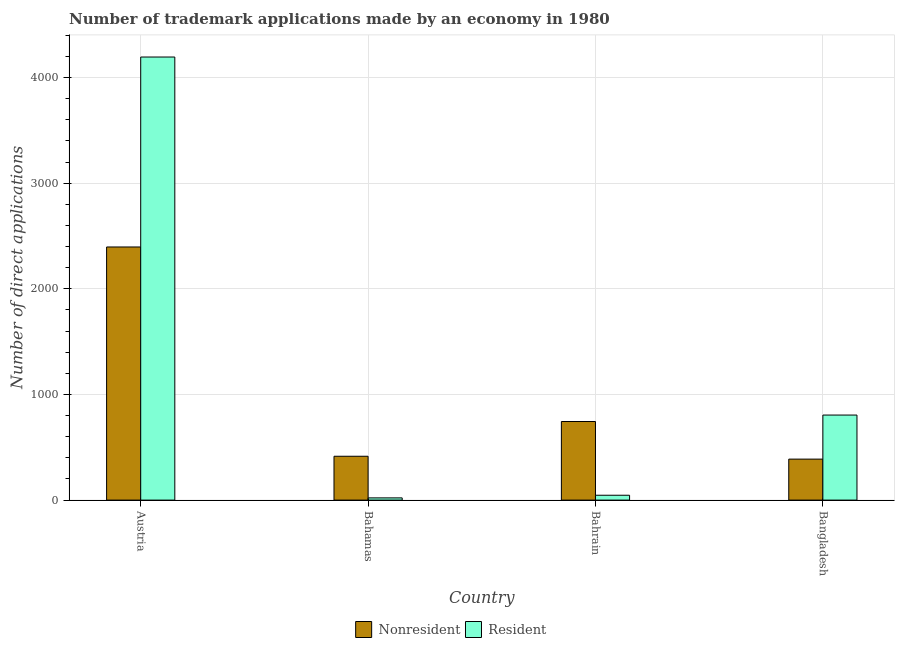Are the number of bars on each tick of the X-axis equal?
Your answer should be very brief. Yes. How many bars are there on the 2nd tick from the left?
Give a very brief answer. 2. How many bars are there on the 2nd tick from the right?
Your response must be concise. 2. What is the label of the 3rd group of bars from the left?
Provide a succinct answer. Bahrain. What is the number of trademark applications made by non residents in Bahrain?
Your answer should be compact. 744. Across all countries, what is the maximum number of trademark applications made by residents?
Give a very brief answer. 4194. Across all countries, what is the minimum number of trademark applications made by non residents?
Your response must be concise. 388. What is the total number of trademark applications made by residents in the graph?
Your response must be concise. 5066. What is the difference between the number of trademark applications made by non residents in Austria and that in Bahrain?
Provide a succinct answer. 1652. What is the difference between the number of trademark applications made by residents in Bangladesh and the number of trademark applications made by non residents in Bahrain?
Make the answer very short. 61. What is the average number of trademark applications made by residents per country?
Ensure brevity in your answer.  1266.5. What is the difference between the number of trademark applications made by non residents and number of trademark applications made by residents in Bahamas?
Offer a very short reply. 394. In how many countries, is the number of trademark applications made by residents greater than 1600 ?
Give a very brief answer. 1. What is the ratio of the number of trademark applications made by residents in Bahrain to that in Bangladesh?
Your response must be concise. 0.06. Is the number of trademark applications made by residents in Austria less than that in Bangladesh?
Your answer should be compact. No. Is the difference between the number of trademark applications made by residents in Bahamas and Bangladesh greater than the difference between the number of trademark applications made by non residents in Bahamas and Bangladesh?
Make the answer very short. No. What is the difference between the highest and the second highest number of trademark applications made by non residents?
Provide a succinct answer. 1652. What is the difference between the highest and the lowest number of trademark applications made by residents?
Make the answer very short. 4173. In how many countries, is the number of trademark applications made by non residents greater than the average number of trademark applications made by non residents taken over all countries?
Offer a terse response. 1. What does the 1st bar from the left in Bangladesh represents?
Your answer should be very brief. Nonresident. What does the 2nd bar from the right in Bahamas represents?
Your answer should be very brief. Nonresident. How many bars are there?
Offer a terse response. 8. What is the difference between two consecutive major ticks on the Y-axis?
Ensure brevity in your answer.  1000. Does the graph contain any zero values?
Your answer should be compact. No. Does the graph contain grids?
Ensure brevity in your answer.  Yes. Where does the legend appear in the graph?
Provide a short and direct response. Bottom center. How many legend labels are there?
Your response must be concise. 2. How are the legend labels stacked?
Make the answer very short. Horizontal. What is the title of the graph?
Provide a short and direct response. Number of trademark applications made by an economy in 1980. What is the label or title of the X-axis?
Provide a succinct answer. Country. What is the label or title of the Y-axis?
Offer a terse response. Number of direct applications. What is the Number of direct applications of Nonresident in Austria?
Offer a very short reply. 2396. What is the Number of direct applications in Resident in Austria?
Provide a short and direct response. 4194. What is the Number of direct applications in Nonresident in Bahamas?
Keep it short and to the point. 415. What is the Number of direct applications of Nonresident in Bahrain?
Offer a terse response. 744. What is the Number of direct applications of Nonresident in Bangladesh?
Provide a succinct answer. 388. What is the Number of direct applications in Resident in Bangladesh?
Your answer should be very brief. 805. Across all countries, what is the maximum Number of direct applications in Nonresident?
Keep it short and to the point. 2396. Across all countries, what is the maximum Number of direct applications in Resident?
Your answer should be very brief. 4194. Across all countries, what is the minimum Number of direct applications of Nonresident?
Offer a terse response. 388. Across all countries, what is the minimum Number of direct applications of Resident?
Ensure brevity in your answer.  21. What is the total Number of direct applications in Nonresident in the graph?
Ensure brevity in your answer.  3943. What is the total Number of direct applications in Resident in the graph?
Your response must be concise. 5066. What is the difference between the Number of direct applications of Nonresident in Austria and that in Bahamas?
Give a very brief answer. 1981. What is the difference between the Number of direct applications in Resident in Austria and that in Bahamas?
Your response must be concise. 4173. What is the difference between the Number of direct applications in Nonresident in Austria and that in Bahrain?
Provide a short and direct response. 1652. What is the difference between the Number of direct applications of Resident in Austria and that in Bahrain?
Offer a very short reply. 4148. What is the difference between the Number of direct applications in Nonresident in Austria and that in Bangladesh?
Provide a succinct answer. 2008. What is the difference between the Number of direct applications in Resident in Austria and that in Bangladesh?
Offer a terse response. 3389. What is the difference between the Number of direct applications in Nonresident in Bahamas and that in Bahrain?
Keep it short and to the point. -329. What is the difference between the Number of direct applications of Nonresident in Bahamas and that in Bangladesh?
Ensure brevity in your answer.  27. What is the difference between the Number of direct applications of Resident in Bahamas and that in Bangladesh?
Provide a succinct answer. -784. What is the difference between the Number of direct applications in Nonresident in Bahrain and that in Bangladesh?
Ensure brevity in your answer.  356. What is the difference between the Number of direct applications of Resident in Bahrain and that in Bangladesh?
Your response must be concise. -759. What is the difference between the Number of direct applications of Nonresident in Austria and the Number of direct applications of Resident in Bahamas?
Keep it short and to the point. 2375. What is the difference between the Number of direct applications of Nonresident in Austria and the Number of direct applications of Resident in Bahrain?
Provide a succinct answer. 2350. What is the difference between the Number of direct applications in Nonresident in Austria and the Number of direct applications in Resident in Bangladesh?
Ensure brevity in your answer.  1591. What is the difference between the Number of direct applications of Nonresident in Bahamas and the Number of direct applications of Resident in Bahrain?
Make the answer very short. 369. What is the difference between the Number of direct applications of Nonresident in Bahamas and the Number of direct applications of Resident in Bangladesh?
Offer a very short reply. -390. What is the difference between the Number of direct applications of Nonresident in Bahrain and the Number of direct applications of Resident in Bangladesh?
Ensure brevity in your answer.  -61. What is the average Number of direct applications of Nonresident per country?
Offer a very short reply. 985.75. What is the average Number of direct applications of Resident per country?
Give a very brief answer. 1266.5. What is the difference between the Number of direct applications of Nonresident and Number of direct applications of Resident in Austria?
Your answer should be very brief. -1798. What is the difference between the Number of direct applications in Nonresident and Number of direct applications in Resident in Bahamas?
Keep it short and to the point. 394. What is the difference between the Number of direct applications of Nonresident and Number of direct applications of Resident in Bahrain?
Offer a very short reply. 698. What is the difference between the Number of direct applications in Nonresident and Number of direct applications in Resident in Bangladesh?
Provide a succinct answer. -417. What is the ratio of the Number of direct applications of Nonresident in Austria to that in Bahamas?
Keep it short and to the point. 5.77. What is the ratio of the Number of direct applications in Resident in Austria to that in Bahamas?
Your answer should be very brief. 199.71. What is the ratio of the Number of direct applications of Nonresident in Austria to that in Bahrain?
Your answer should be compact. 3.22. What is the ratio of the Number of direct applications in Resident in Austria to that in Bahrain?
Ensure brevity in your answer.  91.17. What is the ratio of the Number of direct applications of Nonresident in Austria to that in Bangladesh?
Your response must be concise. 6.18. What is the ratio of the Number of direct applications in Resident in Austria to that in Bangladesh?
Provide a short and direct response. 5.21. What is the ratio of the Number of direct applications in Nonresident in Bahamas to that in Bahrain?
Offer a very short reply. 0.56. What is the ratio of the Number of direct applications of Resident in Bahamas to that in Bahrain?
Offer a terse response. 0.46. What is the ratio of the Number of direct applications of Nonresident in Bahamas to that in Bangladesh?
Offer a very short reply. 1.07. What is the ratio of the Number of direct applications of Resident in Bahamas to that in Bangladesh?
Give a very brief answer. 0.03. What is the ratio of the Number of direct applications in Nonresident in Bahrain to that in Bangladesh?
Give a very brief answer. 1.92. What is the ratio of the Number of direct applications of Resident in Bahrain to that in Bangladesh?
Make the answer very short. 0.06. What is the difference between the highest and the second highest Number of direct applications of Nonresident?
Give a very brief answer. 1652. What is the difference between the highest and the second highest Number of direct applications in Resident?
Your response must be concise. 3389. What is the difference between the highest and the lowest Number of direct applications of Nonresident?
Provide a succinct answer. 2008. What is the difference between the highest and the lowest Number of direct applications of Resident?
Make the answer very short. 4173. 